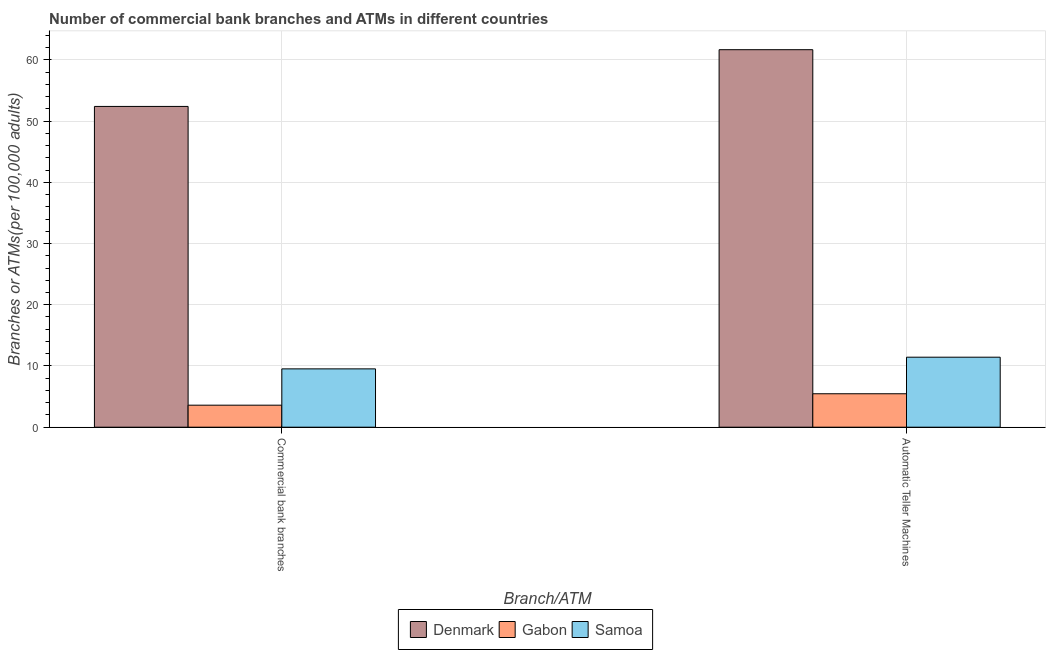How many different coloured bars are there?
Your response must be concise. 3. Are the number of bars per tick equal to the number of legend labels?
Provide a succinct answer. Yes. Are the number of bars on each tick of the X-axis equal?
Ensure brevity in your answer.  Yes. How many bars are there on the 2nd tick from the left?
Provide a short and direct response. 3. What is the label of the 1st group of bars from the left?
Offer a terse response. Commercial bank branches. What is the number of atms in Gabon?
Ensure brevity in your answer.  5.46. Across all countries, what is the maximum number of atms?
Give a very brief answer. 61.66. Across all countries, what is the minimum number of atms?
Give a very brief answer. 5.46. In which country was the number of commercal bank branches minimum?
Your answer should be compact. Gabon. What is the total number of atms in the graph?
Your answer should be compact. 78.55. What is the difference between the number of atms in Gabon and that in Samoa?
Your answer should be very brief. -5.97. What is the difference between the number of atms in Samoa and the number of commercal bank branches in Gabon?
Make the answer very short. 7.84. What is the average number of commercal bank branches per country?
Your answer should be compact. 21.84. What is the difference between the number of atms and number of commercal bank branches in Denmark?
Make the answer very short. 9.27. What is the ratio of the number of commercal bank branches in Samoa to that in Denmark?
Ensure brevity in your answer.  0.18. Is the number of commercal bank branches in Denmark less than that in Gabon?
Your answer should be very brief. No. What does the 2nd bar from the left in Commercial bank branches represents?
Offer a terse response. Gabon. What does the 1st bar from the right in Commercial bank branches represents?
Offer a terse response. Samoa. Are the values on the major ticks of Y-axis written in scientific E-notation?
Ensure brevity in your answer.  No. Does the graph contain any zero values?
Offer a terse response. No. Does the graph contain grids?
Give a very brief answer. Yes. How many legend labels are there?
Offer a very short reply. 3. How are the legend labels stacked?
Offer a very short reply. Horizontal. What is the title of the graph?
Give a very brief answer. Number of commercial bank branches and ATMs in different countries. Does "Morocco" appear as one of the legend labels in the graph?
Your answer should be very brief. No. What is the label or title of the X-axis?
Your answer should be very brief. Branch/ATM. What is the label or title of the Y-axis?
Your response must be concise. Branches or ATMs(per 100,0 adults). What is the Branches or ATMs(per 100,000 adults) in Denmark in Commercial bank branches?
Ensure brevity in your answer.  52.39. What is the Branches or ATMs(per 100,000 adults) in Gabon in Commercial bank branches?
Give a very brief answer. 3.6. What is the Branches or ATMs(per 100,000 adults) in Samoa in Commercial bank branches?
Provide a succinct answer. 9.53. What is the Branches or ATMs(per 100,000 adults) of Denmark in Automatic Teller Machines?
Ensure brevity in your answer.  61.66. What is the Branches or ATMs(per 100,000 adults) of Gabon in Automatic Teller Machines?
Give a very brief answer. 5.46. What is the Branches or ATMs(per 100,000 adults) of Samoa in Automatic Teller Machines?
Offer a very short reply. 11.43. Across all Branch/ATM, what is the maximum Branches or ATMs(per 100,000 adults) in Denmark?
Provide a short and direct response. 61.66. Across all Branch/ATM, what is the maximum Branches or ATMs(per 100,000 adults) of Gabon?
Provide a succinct answer. 5.46. Across all Branch/ATM, what is the maximum Branches or ATMs(per 100,000 adults) of Samoa?
Make the answer very short. 11.43. Across all Branch/ATM, what is the minimum Branches or ATMs(per 100,000 adults) in Denmark?
Give a very brief answer. 52.39. Across all Branch/ATM, what is the minimum Branches or ATMs(per 100,000 adults) in Gabon?
Ensure brevity in your answer.  3.6. Across all Branch/ATM, what is the minimum Branches or ATMs(per 100,000 adults) in Samoa?
Your answer should be very brief. 9.53. What is the total Branches or ATMs(per 100,000 adults) of Denmark in the graph?
Your answer should be very brief. 114.05. What is the total Branches or ATMs(per 100,000 adults) in Gabon in the graph?
Offer a terse response. 9.06. What is the total Branches or ATMs(per 100,000 adults) of Samoa in the graph?
Keep it short and to the point. 20.96. What is the difference between the Branches or ATMs(per 100,000 adults) of Denmark in Commercial bank branches and that in Automatic Teller Machines?
Give a very brief answer. -9.27. What is the difference between the Branches or ATMs(per 100,000 adults) in Gabon in Commercial bank branches and that in Automatic Teller Machines?
Provide a short and direct response. -1.86. What is the difference between the Branches or ATMs(per 100,000 adults) of Samoa in Commercial bank branches and that in Automatic Teller Machines?
Provide a short and direct response. -1.91. What is the difference between the Branches or ATMs(per 100,000 adults) in Denmark in Commercial bank branches and the Branches or ATMs(per 100,000 adults) in Gabon in Automatic Teller Machines?
Your answer should be compact. 46.93. What is the difference between the Branches or ATMs(per 100,000 adults) in Denmark in Commercial bank branches and the Branches or ATMs(per 100,000 adults) in Samoa in Automatic Teller Machines?
Keep it short and to the point. 40.96. What is the difference between the Branches or ATMs(per 100,000 adults) of Gabon in Commercial bank branches and the Branches or ATMs(per 100,000 adults) of Samoa in Automatic Teller Machines?
Ensure brevity in your answer.  -7.84. What is the average Branches or ATMs(per 100,000 adults) in Denmark per Branch/ATM?
Offer a terse response. 57.02. What is the average Branches or ATMs(per 100,000 adults) of Gabon per Branch/ATM?
Your answer should be compact. 4.53. What is the average Branches or ATMs(per 100,000 adults) in Samoa per Branch/ATM?
Offer a very short reply. 10.48. What is the difference between the Branches or ATMs(per 100,000 adults) of Denmark and Branches or ATMs(per 100,000 adults) of Gabon in Commercial bank branches?
Your answer should be compact. 48.79. What is the difference between the Branches or ATMs(per 100,000 adults) in Denmark and Branches or ATMs(per 100,000 adults) in Samoa in Commercial bank branches?
Keep it short and to the point. 42.86. What is the difference between the Branches or ATMs(per 100,000 adults) in Gabon and Branches or ATMs(per 100,000 adults) in Samoa in Commercial bank branches?
Give a very brief answer. -5.93. What is the difference between the Branches or ATMs(per 100,000 adults) of Denmark and Branches or ATMs(per 100,000 adults) of Gabon in Automatic Teller Machines?
Offer a terse response. 56.2. What is the difference between the Branches or ATMs(per 100,000 adults) in Denmark and Branches or ATMs(per 100,000 adults) in Samoa in Automatic Teller Machines?
Ensure brevity in your answer.  50.22. What is the difference between the Branches or ATMs(per 100,000 adults) of Gabon and Branches or ATMs(per 100,000 adults) of Samoa in Automatic Teller Machines?
Keep it short and to the point. -5.97. What is the ratio of the Branches or ATMs(per 100,000 adults) of Denmark in Commercial bank branches to that in Automatic Teller Machines?
Give a very brief answer. 0.85. What is the ratio of the Branches or ATMs(per 100,000 adults) of Gabon in Commercial bank branches to that in Automatic Teller Machines?
Your answer should be very brief. 0.66. What is the ratio of the Branches or ATMs(per 100,000 adults) of Samoa in Commercial bank branches to that in Automatic Teller Machines?
Your answer should be compact. 0.83. What is the difference between the highest and the second highest Branches or ATMs(per 100,000 adults) in Denmark?
Your answer should be very brief. 9.27. What is the difference between the highest and the second highest Branches or ATMs(per 100,000 adults) of Gabon?
Offer a terse response. 1.86. What is the difference between the highest and the second highest Branches or ATMs(per 100,000 adults) of Samoa?
Ensure brevity in your answer.  1.91. What is the difference between the highest and the lowest Branches or ATMs(per 100,000 adults) in Denmark?
Ensure brevity in your answer.  9.27. What is the difference between the highest and the lowest Branches or ATMs(per 100,000 adults) in Gabon?
Offer a terse response. 1.86. What is the difference between the highest and the lowest Branches or ATMs(per 100,000 adults) of Samoa?
Offer a terse response. 1.91. 